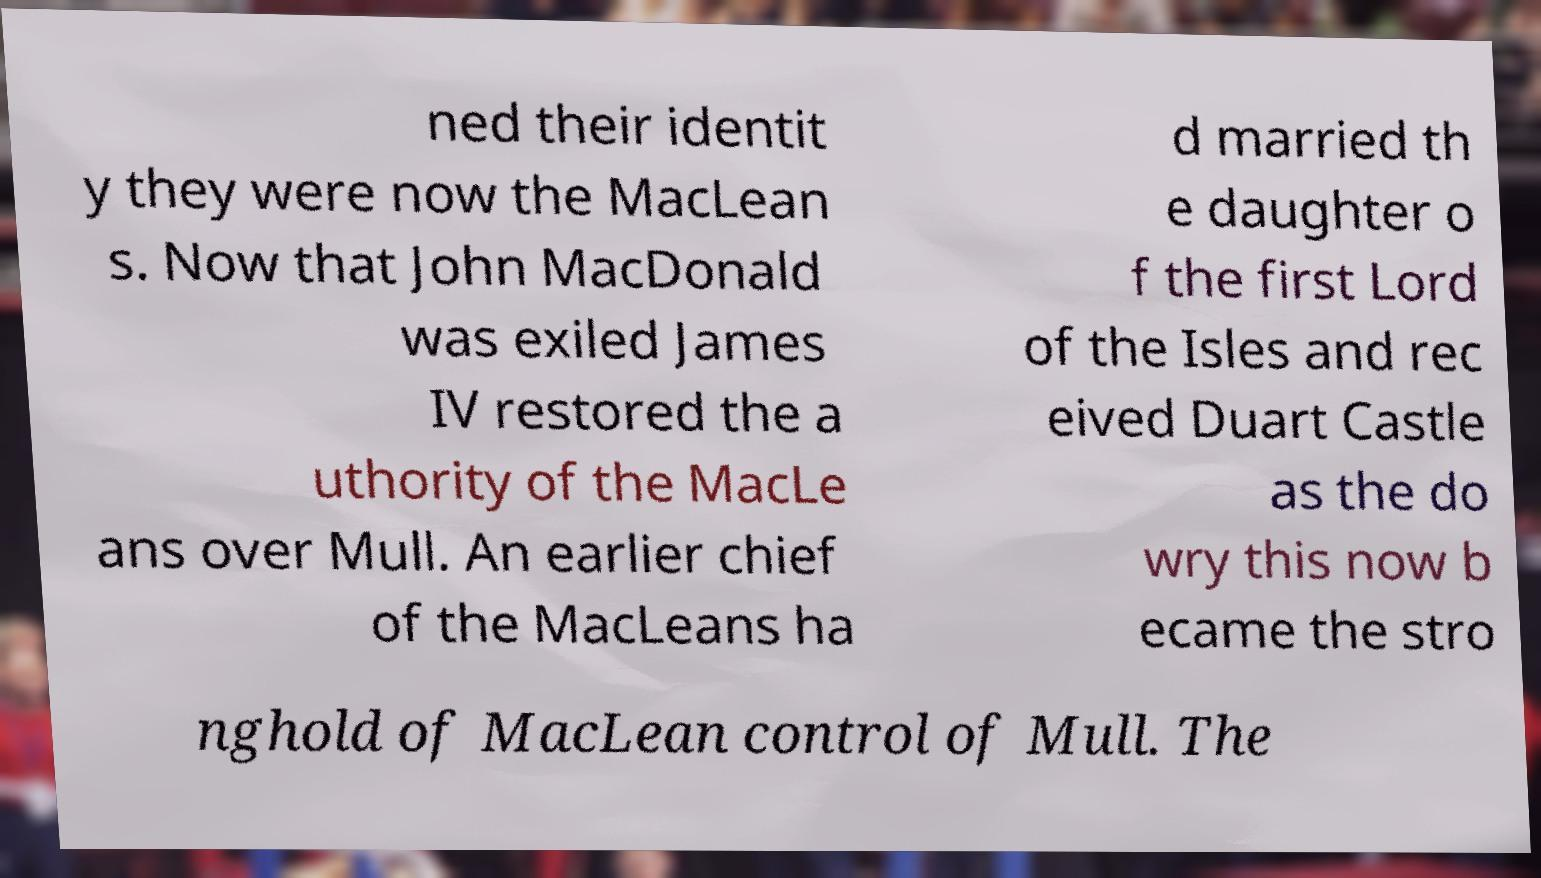What messages or text are displayed in this image? I need them in a readable, typed format. ned their identit y they were now the MacLean s. Now that John MacDonald was exiled James IV restored the a uthority of the MacLe ans over Mull. An earlier chief of the MacLeans ha d married th e daughter o f the first Lord of the Isles and rec eived Duart Castle as the do wry this now b ecame the stro nghold of MacLean control of Mull. The 